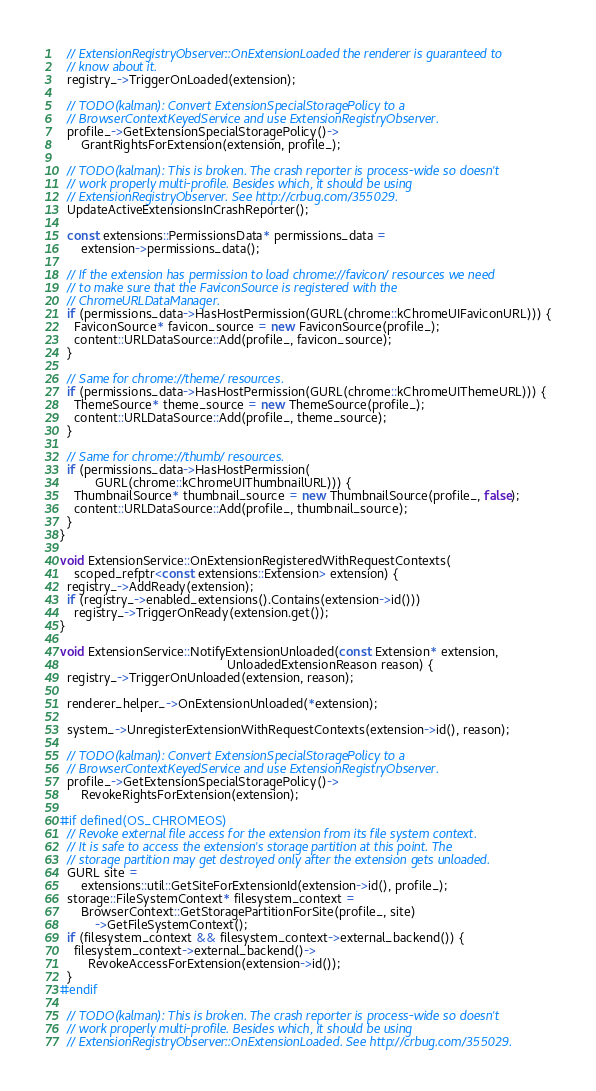<code> <loc_0><loc_0><loc_500><loc_500><_C++_>  // ExtensionRegistryObserver::OnExtensionLoaded the renderer is guaranteed to
  // know about it.
  registry_->TriggerOnLoaded(extension);

  // TODO(kalman): Convert ExtensionSpecialStoragePolicy to a
  // BrowserContextKeyedService and use ExtensionRegistryObserver.
  profile_->GetExtensionSpecialStoragePolicy()->
      GrantRightsForExtension(extension, profile_);

  // TODO(kalman): This is broken. The crash reporter is process-wide so doesn't
  // work properly multi-profile. Besides which, it should be using
  // ExtensionRegistryObserver. See http://crbug.com/355029.
  UpdateActiveExtensionsInCrashReporter();

  const extensions::PermissionsData* permissions_data =
      extension->permissions_data();

  // If the extension has permission to load chrome://favicon/ resources we need
  // to make sure that the FaviconSource is registered with the
  // ChromeURLDataManager.
  if (permissions_data->HasHostPermission(GURL(chrome::kChromeUIFaviconURL))) {
    FaviconSource* favicon_source = new FaviconSource(profile_);
    content::URLDataSource::Add(profile_, favicon_source);
  }

  // Same for chrome://theme/ resources.
  if (permissions_data->HasHostPermission(GURL(chrome::kChromeUIThemeURL))) {
    ThemeSource* theme_source = new ThemeSource(profile_);
    content::URLDataSource::Add(profile_, theme_source);
  }

  // Same for chrome://thumb/ resources.
  if (permissions_data->HasHostPermission(
          GURL(chrome::kChromeUIThumbnailURL))) {
    ThumbnailSource* thumbnail_source = new ThumbnailSource(profile_, false);
    content::URLDataSource::Add(profile_, thumbnail_source);
  }
}

void ExtensionService::OnExtensionRegisteredWithRequestContexts(
    scoped_refptr<const extensions::Extension> extension) {
  registry_->AddReady(extension);
  if (registry_->enabled_extensions().Contains(extension->id()))
    registry_->TriggerOnReady(extension.get());
}

void ExtensionService::NotifyExtensionUnloaded(const Extension* extension,
                                               UnloadedExtensionReason reason) {
  registry_->TriggerOnUnloaded(extension, reason);

  renderer_helper_->OnExtensionUnloaded(*extension);

  system_->UnregisterExtensionWithRequestContexts(extension->id(), reason);

  // TODO(kalman): Convert ExtensionSpecialStoragePolicy to a
  // BrowserContextKeyedService and use ExtensionRegistryObserver.
  profile_->GetExtensionSpecialStoragePolicy()->
      RevokeRightsForExtension(extension);

#if defined(OS_CHROMEOS)
  // Revoke external file access for the extension from its file system context.
  // It is safe to access the extension's storage partition at this point. The
  // storage partition may get destroyed only after the extension gets unloaded.
  GURL site =
      extensions::util::GetSiteForExtensionId(extension->id(), profile_);
  storage::FileSystemContext* filesystem_context =
      BrowserContext::GetStoragePartitionForSite(profile_, site)
          ->GetFileSystemContext();
  if (filesystem_context && filesystem_context->external_backend()) {
    filesystem_context->external_backend()->
        RevokeAccessForExtension(extension->id());
  }
#endif

  // TODO(kalman): This is broken. The crash reporter is process-wide so doesn't
  // work properly multi-profile. Besides which, it should be using
  // ExtensionRegistryObserver::OnExtensionLoaded. See http://crbug.com/355029.</code> 